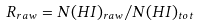Convert formula to latex. <formula><loc_0><loc_0><loc_500><loc_500>R _ { r a w } = N ( H I ) _ { r a w } / N ( H I ) _ { t o t }</formula> 